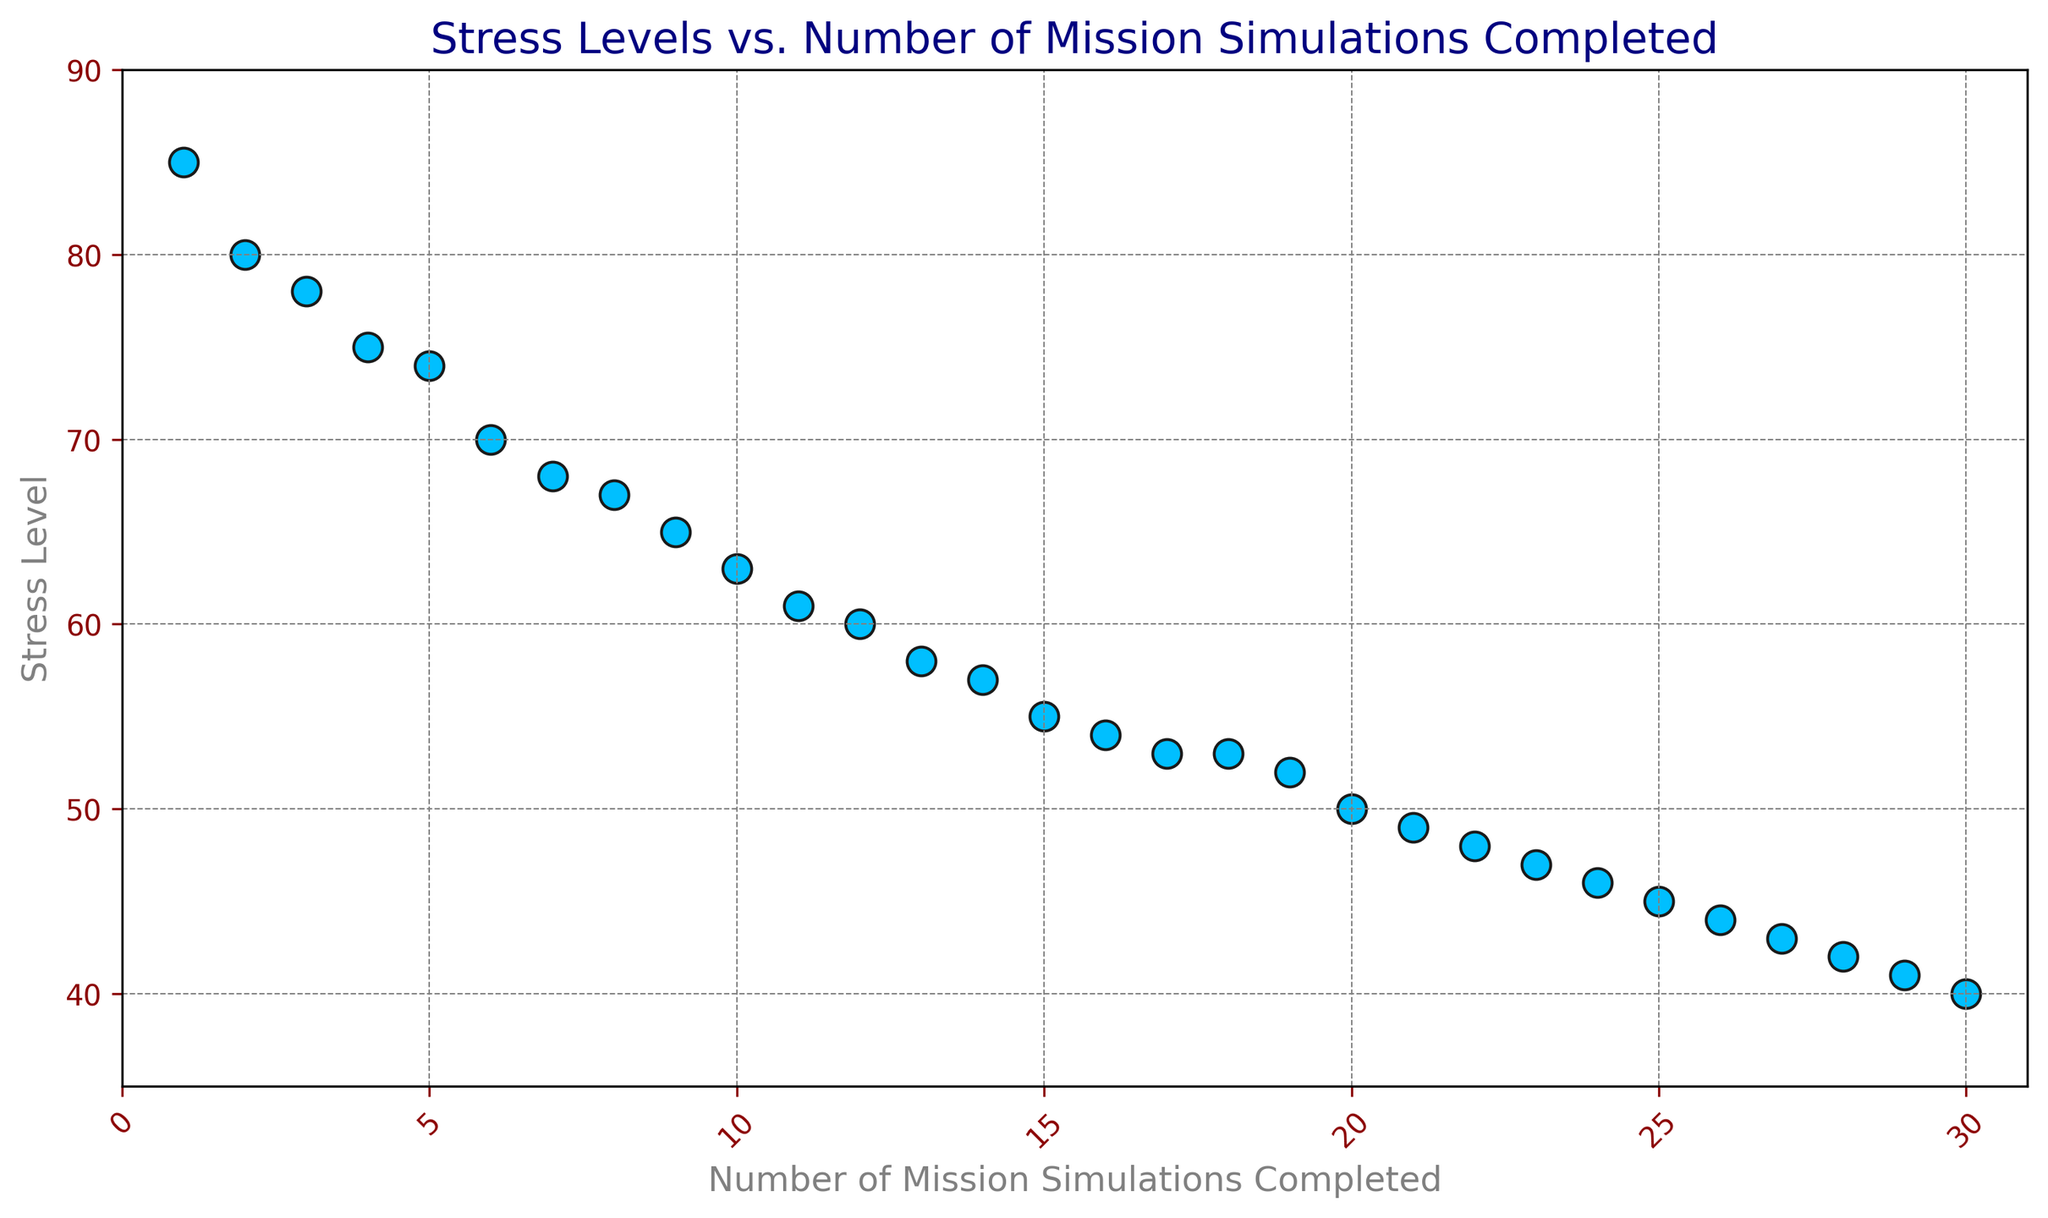What is the stress level for the astronaut who completed the 10th mission simulation? Locate the data point corresponding to the 10th mission simulation on the x-axis and see the stress level value on the y-axis.
Answer: 63 How does the stress level change as the number of mission simulations increases? Observe the trend of the plotted data. As the number of simulations increases, the stress level generally decreases, indicating a negative correlation.
Answer: Decreases What is the difference in stress levels between the 5th and 25th mission simulations? Find the stress levels for the 5th and 25th simulations (74 and 45, respectively), and compute the difference: 74 - 45.
Answer: 29 What is the average stress level during the first 10 mission simulations? Add up the stress levels from the 1st to the 10th simulation (85+80+78+75+74+70+68+67+65+63) and divide by 10.
Answer: 72.5 What is the trend between the number of mission simulations and the stress level in the last 5 simulations? Look at the data points from the 26th to the 30th simulations. The stress levels appear to decrease steadily from 44 to 40, indicating a downward trend.
Answer: Downward trend Is there a point where the stress level stops decreasing and plateaus? Identify if there's a part of the plot where the stress level does not change significantly. This occurs around simulations 17 to 18 where the stress level remains at 53.
Answer: Yes, 17-18 What can you infer about the relationship between the number of mission simulations and stress level variance? Observe the spread of the data points. The variance in stress levels decreases as the number of simulations increases, implying a reduction in stress variability as experience grows.
Answer: Decreased variance Which simulation saw the largest drop in stress level compared to its previous simulation? Calculate the differences between consecutive stress levels. The largest drop is from 80 in the 2nd simulation to 78 in the 3rd simulation, a drop of 2 points.
Answer: 2nd to 3rd simulation How does visual appearance (color, shape, size) help in interpreting the scatter plot? The data points are represented by blue circles with black edges. The color and size help distinguish the points clearly, and the consistent shape aids in spotting trends and patterns.
Answer: Clarity and trend visibility What is the stress level for the astronaut after completing 30 mission simulations? Find the data point on the x-axis at 30 and look at its corresponding y-axis value.
Answer: 40 